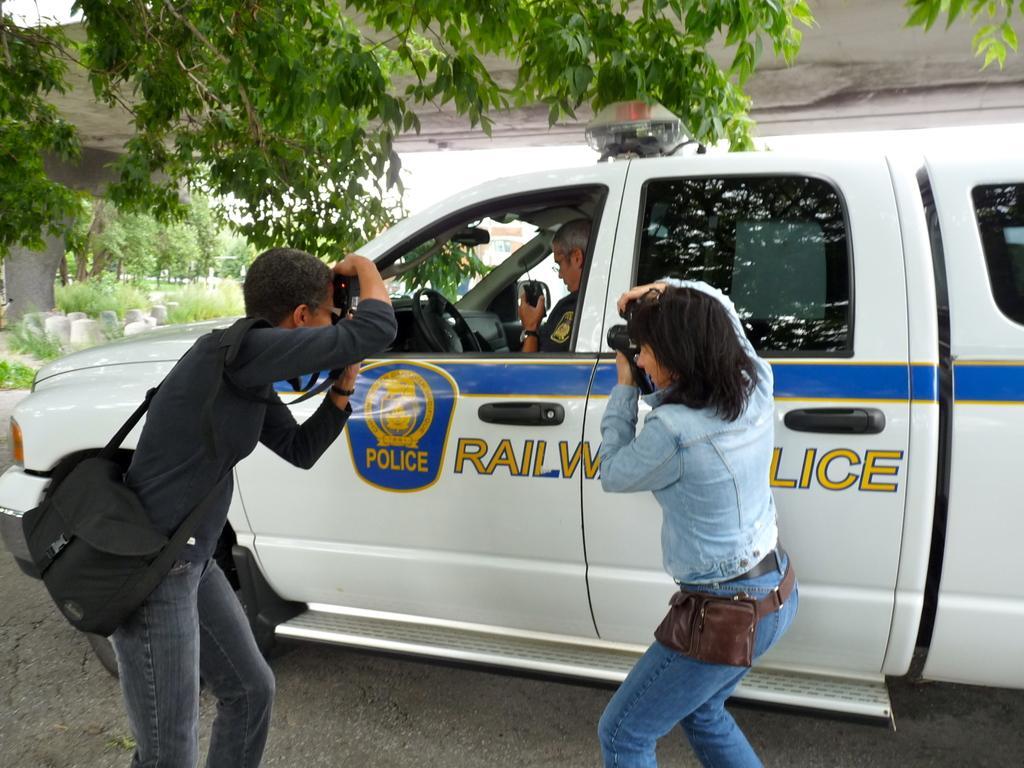Describe this image in one or two sentences. In this image we can see two persons holding a camera and the man is wearing a bag. In the car there is a person sitting. At the background we can see trees. 